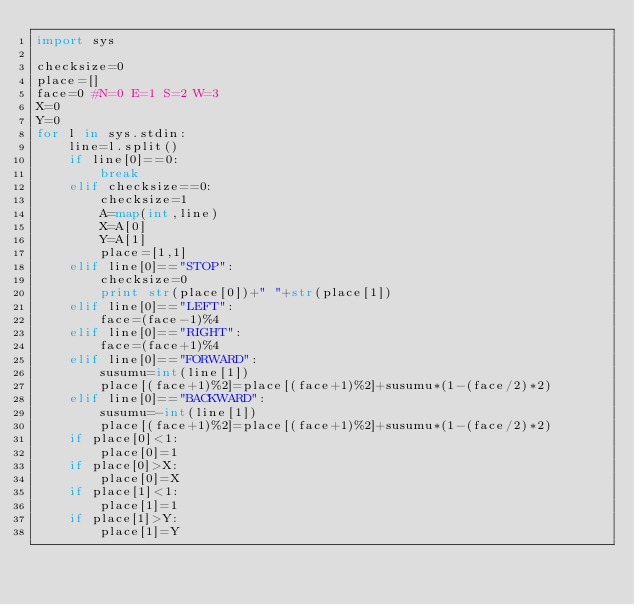Convert code to text. <code><loc_0><loc_0><loc_500><loc_500><_Python_>import sys

checksize=0
place=[]
face=0 #N=0 E=1 S=2 W=3
X=0
Y=0
for l in sys.stdin:
    line=l.split()
    if line[0]==0:
        break
    elif checksize==0:
        checksize=1
        A=map(int,line)
        X=A[0]
        Y=A[1]
        place=[1,1]
    elif line[0]=="STOP":
        checksize=0
        print str(place[0])+" "+str(place[1])
    elif line[0]=="LEFT":
        face=(face-1)%4
    elif line[0]=="RIGHT":
        face=(face+1)%4
    elif line[0]=="FORWARD":
        susumu=int(line[1])
        place[(face+1)%2]=place[(face+1)%2]+susumu*(1-(face/2)*2)
    elif line[0]=="BACKWARD":
        susumu=-int(line[1])
        place[(face+1)%2]=place[(face+1)%2]+susumu*(1-(face/2)*2)
    if place[0]<1:
        place[0]=1
    if place[0]>X:
        place[0]=X
    if place[1]<1:
        place[1]=1
    if place[1]>Y:
        place[1]=Y</code> 